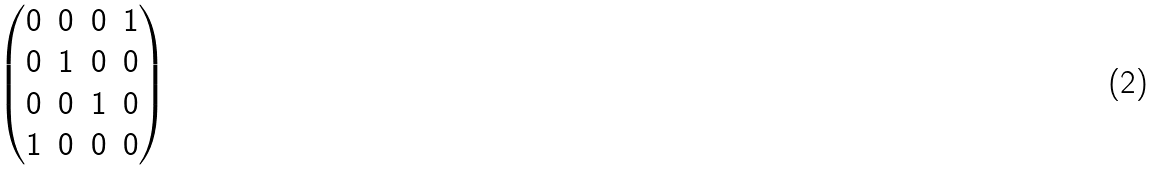<formula> <loc_0><loc_0><loc_500><loc_500>\begin{pmatrix} 0 & 0 & 0 & 1 \\ 0 & 1 & 0 & 0 \\ 0 & 0 & 1 & 0 \\ 1 & 0 & 0 & 0 \\ \end{pmatrix}</formula> 